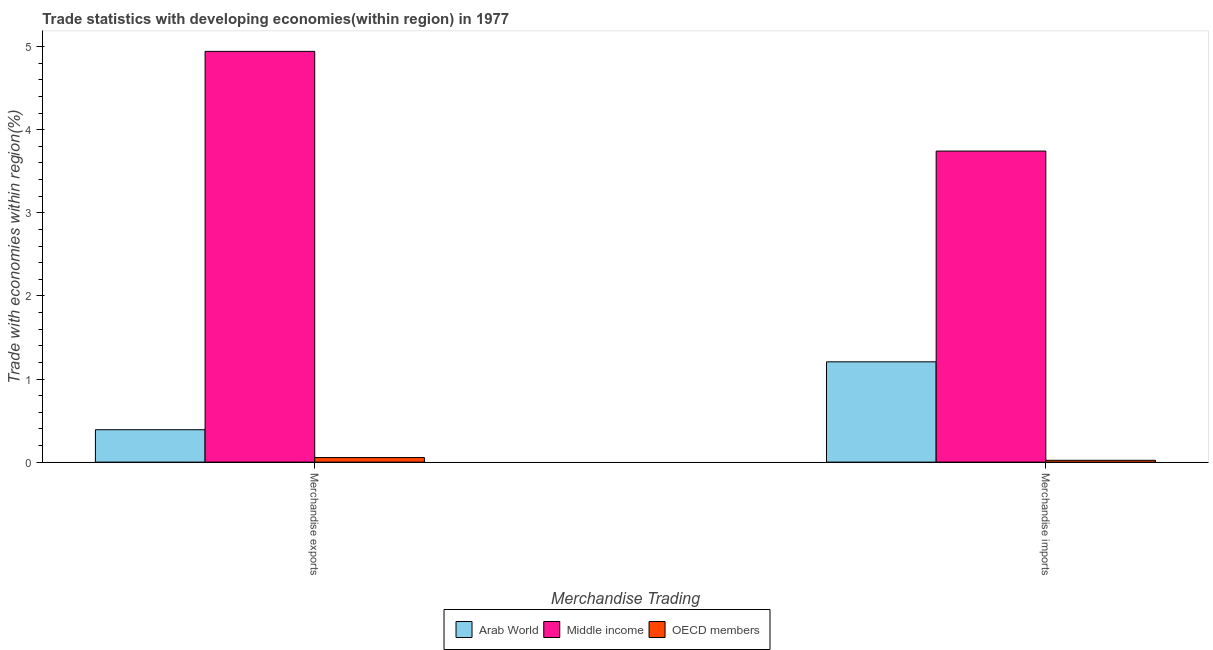How many different coloured bars are there?
Offer a terse response. 3. How many groups of bars are there?
Your answer should be compact. 2. Are the number of bars per tick equal to the number of legend labels?
Provide a succinct answer. Yes. What is the merchandise exports in OECD members?
Provide a short and direct response. 0.06. Across all countries, what is the maximum merchandise imports?
Ensure brevity in your answer.  3.74. Across all countries, what is the minimum merchandise imports?
Provide a succinct answer. 0.02. In which country was the merchandise exports maximum?
Give a very brief answer. Middle income. What is the total merchandise exports in the graph?
Offer a very short reply. 5.39. What is the difference between the merchandise imports in Middle income and that in Arab World?
Offer a terse response. 2.54. What is the difference between the merchandise imports in Middle income and the merchandise exports in OECD members?
Offer a very short reply. 3.69. What is the average merchandise imports per country?
Offer a very short reply. 1.66. What is the difference between the merchandise imports and merchandise exports in Arab World?
Offer a very short reply. 0.82. What is the ratio of the merchandise exports in Middle income to that in Arab World?
Provide a succinct answer. 12.68. Is the merchandise exports in Middle income less than that in OECD members?
Ensure brevity in your answer.  No. What does the 3rd bar from the right in Merchandise imports represents?
Offer a terse response. Arab World. Are all the bars in the graph horizontal?
Your response must be concise. No. Does the graph contain any zero values?
Your response must be concise. No. How many legend labels are there?
Provide a short and direct response. 3. How are the legend labels stacked?
Provide a succinct answer. Horizontal. What is the title of the graph?
Provide a short and direct response. Trade statistics with developing economies(within region) in 1977. What is the label or title of the X-axis?
Give a very brief answer. Merchandise Trading. What is the label or title of the Y-axis?
Offer a very short reply. Trade with economies within region(%). What is the Trade with economies within region(%) in Arab World in Merchandise exports?
Make the answer very short. 0.39. What is the Trade with economies within region(%) of Middle income in Merchandise exports?
Your response must be concise. 4.94. What is the Trade with economies within region(%) in OECD members in Merchandise exports?
Provide a succinct answer. 0.06. What is the Trade with economies within region(%) in Arab World in Merchandise imports?
Give a very brief answer. 1.21. What is the Trade with economies within region(%) in Middle income in Merchandise imports?
Your answer should be compact. 3.74. What is the Trade with economies within region(%) in OECD members in Merchandise imports?
Provide a short and direct response. 0.02. Across all Merchandise Trading, what is the maximum Trade with economies within region(%) of Arab World?
Your answer should be very brief. 1.21. Across all Merchandise Trading, what is the maximum Trade with economies within region(%) in Middle income?
Keep it short and to the point. 4.94. Across all Merchandise Trading, what is the maximum Trade with economies within region(%) of OECD members?
Keep it short and to the point. 0.06. Across all Merchandise Trading, what is the minimum Trade with economies within region(%) of Arab World?
Keep it short and to the point. 0.39. Across all Merchandise Trading, what is the minimum Trade with economies within region(%) of Middle income?
Ensure brevity in your answer.  3.74. Across all Merchandise Trading, what is the minimum Trade with economies within region(%) in OECD members?
Offer a terse response. 0.02. What is the total Trade with economies within region(%) of Arab World in the graph?
Your response must be concise. 1.6. What is the total Trade with economies within region(%) of Middle income in the graph?
Ensure brevity in your answer.  8.69. What is the total Trade with economies within region(%) of OECD members in the graph?
Offer a terse response. 0.08. What is the difference between the Trade with economies within region(%) of Arab World in Merchandise exports and that in Merchandise imports?
Provide a short and direct response. -0.82. What is the difference between the Trade with economies within region(%) in OECD members in Merchandise exports and that in Merchandise imports?
Provide a short and direct response. 0.03. What is the difference between the Trade with economies within region(%) of Arab World in Merchandise exports and the Trade with economies within region(%) of Middle income in Merchandise imports?
Give a very brief answer. -3.35. What is the difference between the Trade with economies within region(%) of Arab World in Merchandise exports and the Trade with economies within region(%) of OECD members in Merchandise imports?
Your answer should be very brief. 0.37. What is the difference between the Trade with economies within region(%) in Middle income in Merchandise exports and the Trade with economies within region(%) in OECD members in Merchandise imports?
Provide a short and direct response. 4.92. What is the average Trade with economies within region(%) in Arab World per Merchandise Trading?
Offer a very short reply. 0.8. What is the average Trade with economies within region(%) of Middle income per Merchandise Trading?
Offer a terse response. 4.34. What is the average Trade with economies within region(%) in OECD members per Merchandise Trading?
Keep it short and to the point. 0.04. What is the difference between the Trade with economies within region(%) in Arab World and Trade with economies within region(%) in Middle income in Merchandise exports?
Ensure brevity in your answer.  -4.55. What is the difference between the Trade with economies within region(%) of Arab World and Trade with economies within region(%) of OECD members in Merchandise exports?
Offer a very short reply. 0.33. What is the difference between the Trade with economies within region(%) of Middle income and Trade with economies within region(%) of OECD members in Merchandise exports?
Ensure brevity in your answer.  4.89. What is the difference between the Trade with economies within region(%) of Arab World and Trade with economies within region(%) of Middle income in Merchandise imports?
Your response must be concise. -2.54. What is the difference between the Trade with economies within region(%) of Arab World and Trade with economies within region(%) of OECD members in Merchandise imports?
Provide a succinct answer. 1.19. What is the difference between the Trade with economies within region(%) of Middle income and Trade with economies within region(%) of OECD members in Merchandise imports?
Ensure brevity in your answer.  3.72. What is the ratio of the Trade with economies within region(%) of Arab World in Merchandise exports to that in Merchandise imports?
Provide a short and direct response. 0.32. What is the ratio of the Trade with economies within region(%) in Middle income in Merchandise exports to that in Merchandise imports?
Provide a succinct answer. 1.32. What is the ratio of the Trade with economies within region(%) of OECD members in Merchandise exports to that in Merchandise imports?
Provide a short and direct response. 2.48. What is the difference between the highest and the second highest Trade with economies within region(%) in Arab World?
Offer a terse response. 0.82. What is the difference between the highest and the second highest Trade with economies within region(%) of Middle income?
Offer a terse response. 1.2. What is the difference between the highest and the second highest Trade with economies within region(%) in OECD members?
Offer a terse response. 0.03. What is the difference between the highest and the lowest Trade with economies within region(%) in Arab World?
Give a very brief answer. 0.82. What is the difference between the highest and the lowest Trade with economies within region(%) of Middle income?
Provide a short and direct response. 1.2. What is the difference between the highest and the lowest Trade with economies within region(%) in OECD members?
Your answer should be very brief. 0.03. 